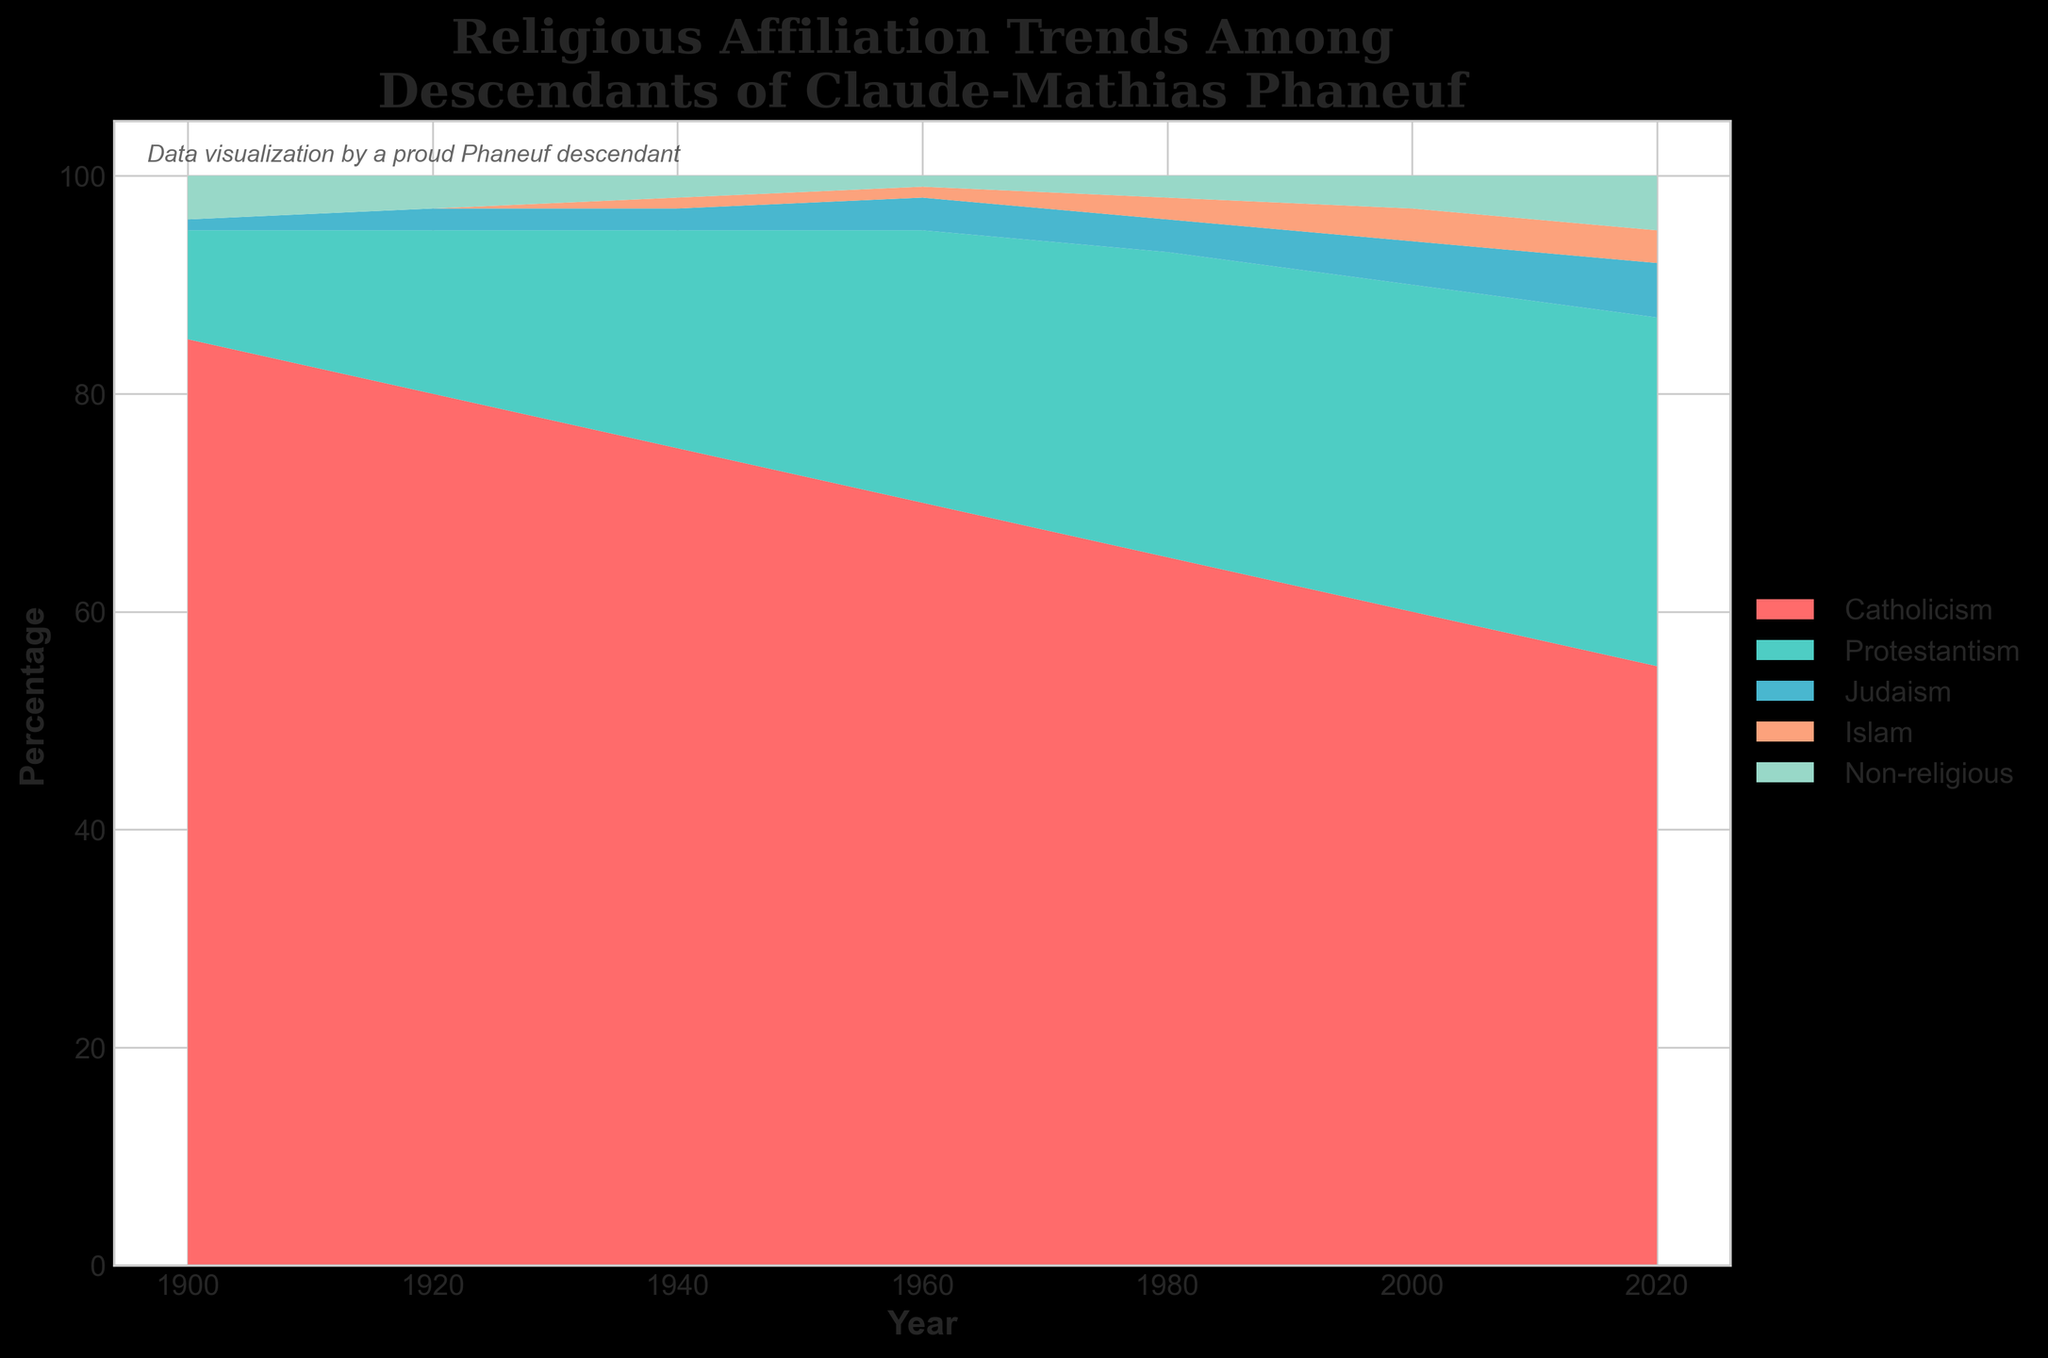What is the title of the figure? The title is displayed at the top of the figure and reads “Religious Affiliation Trends Among Descendants of Claude-Mathias Phaneuf”.
Answer: Religious Affiliation Trends Among Descendants of Claude-Mathias Phaneuf Which religion had the highest percentage in 1900? By looking at the beginning of the streams in 1900, Catholicism has the highest percentage with 85%.
Answer: Catholicism How did the percentage of Non-religious descendants change from 1960 to 2020? We can observe the gradual increase in the Non-religious section colored in a specific hue from 1960 (1%) to 2020 (5%).
Answer: Increased by 4% In which year was the percentage of Protestantism first observed to surpass 30%? By tracing the Protestantism stream, it first crosses the 30% mark around the year 2000.
Answer: 2000 What is the range of years represented in the plot? The x-axis of the figure shows the years ranging from 1900 to 2020.
Answer: 1900 to 2020 Compare the trend of Catholicism and Non-religious groups from 1960 to 2020. Catholicism shows a consistent decrease from 70% in 1960 to 55% in 2020, whereas the Non-religious group shows an increase from 1% in 1960 to 5% in 2020.
Answer: Catholicism decreased, Non-religious increased Which religious group has remained relatively stable over the years? By observing the streams, Judaism has remained relatively stable with a slight increase from 1% to 5% over the years.
Answer: Judaism What was the trend for Islam from 1920 to 2020? Islam first appeared in 1940 with 1% and shows a gradual increase until it reaches 3% in 2000 and remains stable till 2020.
Answer: Gradual increase and stable Which group experienced the most significant drop in percentage from 1900 to 2020? Catholicism experienced the most significant drop, decreasing from 85% in 1900 to 55% in 2020, a reduction of 30%.
Answer: Catholicism What can be inferred about the trend of total religious affiliation versus non-religious over the entire timeline? Total religious affiliation (sum of all religious groups) generally decreased, while the Non-religious group increased over time, indicating a shift towards secularism among descendants.
Answer: Decreased for religion, increased for secularism 